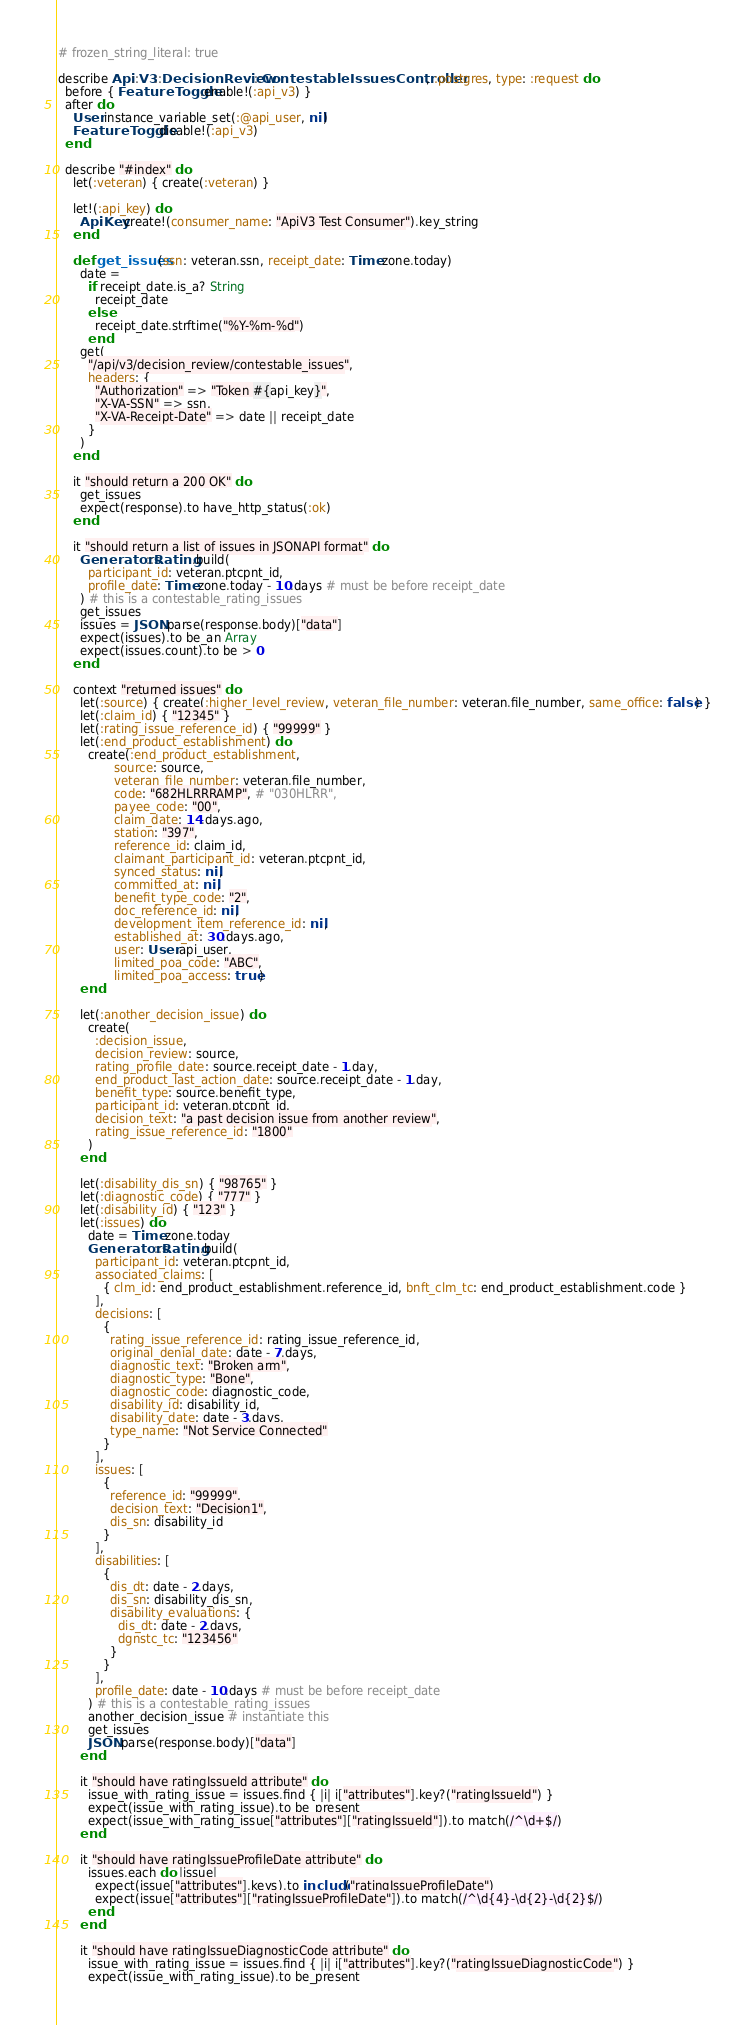<code> <loc_0><loc_0><loc_500><loc_500><_Ruby_># frozen_string_literal: true

describe Api::V3::DecisionReview::ContestableIssuesController, :postgres, type: :request do
  before { FeatureToggle.enable!(:api_v3) }
  after do
    User.instance_variable_set(:@api_user, nil)
    FeatureToggle.disable!(:api_v3)
  end

  describe "#index" do
    let(:veteran) { create(:veteran) }

    let!(:api_key) do
      ApiKey.create!(consumer_name: "ApiV3 Test Consumer").key_string
    end

    def get_issues(ssn: veteran.ssn, receipt_date: Time.zone.today)
      date =
        if receipt_date.is_a? String
          receipt_date
        else
          receipt_date.strftime("%Y-%m-%d")
        end
      get(
        "/api/v3/decision_review/contestable_issues",
        headers: {
          "Authorization" => "Token #{api_key}",
          "X-VA-SSN" => ssn,
          "X-VA-Receipt-Date" => date || receipt_date
        }
      )
    end

    it "should return a 200 OK" do
      get_issues
      expect(response).to have_http_status(:ok)
    end

    it "should return a list of issues in JSONAPI format" do
      Generators::Rating.build(
        participant_id: veteran.ptcpnt_id,
        profile_date: Time.zone.today - 10.days # must be before receipt_date
      ) # this is a contestable_rating_issues
      get_issues
      issues = JSON.parse(response.body)["data"]
      expect(issues).to be_an Array
      expect(issues.count).to be > 0
    end

    context "returned issues" do
      let(:source) { create(:higher_level_review, veteran_file_number: veteran.file_number, same_office: false) }
      let(:claim_id) { "12345" }
      let(:rating_issue_reference_id) { "99999" }
      let(:end_product_establishment) do
        create(:end_product_establishment,
               source: source,
               veteran_file_number: veteran.file_number,
               code: "682HLRRRAMP", # "030HLRR",
               payee_code: "00",
               claim_date: 14.days.ago,
               station: "397",
               reference_id: claim_id,
               claimant_participant_id: veteran.ptcpnt_id,
               synced_status: nil,
               committed_at: nil,
               benefit_type_code: "2",
               doc_reference_id: nil,
               development_item_reference_id: nil,
               established_at: 30.days.ago,
               user: User.api_user,
               limited_poa_code: "ABC",
               limited_poa_access: true)
      end

      let(:another_decision_issue) do
        create(
          :decision_issue,
          decision_review: source,
          rating_profile_date: source.receipt_date - 1.day,
          end_product_last_action_date: source.receipt_date - 1.day,
          benefit_type: source.benefit_type,
          participant_id: veteran.ptcpnt_id,
          decision_text: "a past decision issue from another review",
          rating_issue_reference_id: "1800"
        )
      end

      let(:disability_dis_sn) { "98765" }
      let(:diagnostic_code) { "777" }
      let(:disability_id) { "123" }
      let(:issues) do
        date = Time.zone.today
        Generators::Rating.build(
          participant_id: veteran.ptcpnt_id,
          associated_claims: [
            { clm_id: end_product_establishment.reference_id, bnft_clm_tc: end_product_establishment.code }
          ],
          decisions: [
            {
              rating_issue_reference_id: rating_issue_reference_id,
              original_denial_date: date - 7.days,
              diagnostic_text: "Broken arm",
              diagnostic_type: "Bone",
              diagnostic_code: diagnostic_code,
              disability_id: disability_id,
              disability_date: date - 3.days,
              type_name: "Not Service Connected"
            }
          ],
          issues: [
            {
              reference_id: "99999",
              decision_text: "Decision1",
              dis_sn: disability_id
            }
          ],
          disabilities: [
            {
              dis_dt: date - 2.days,
              dis_sn: disability_dis_sn,
              disability_evaluations: {
                dis_dt: date - 2.days,
                dgnstc_tc: "123456"
              }
            }
          ],
          profile_date: date - 10.days # must be before receipt_date
        ) # this is a contestable_rating_issues
        another_decision_issue # instantiate this
        get_issues
        JSON.parse(response.body)["data"]
      end

      it "should have ratingIssueId attribute" do
        issue_with_rating_issue = issues.find { |i| i["attributes"].key?("ratingIssueId") }
        expect(issue_with_rating_issue).to be_present
        expect(issue_with_rating_issue["attributes"]["ratingIssueId"]).to match(/^\d+$/)
      end

      it "should have ratingIssueProfileDate attribute" do
        issues.each do |issue|
          expect(issue["attributes"].keys).to include("ratingIssueProfileDate")
          expect(issue["attributes"]["ratingIssueProfileDate"]).to match(/^\d{4}-\d{2}-\d{2}$/)
        end
      end

      it "should have ratingIssueDiagnosticCode attribute" do
        issue_with_rating_issue = issues.find { |i| i["attributes"].key?("ratingIssueDiagnosticCode") }
        expect(issue_with_rating_issue).to be_present</code> 